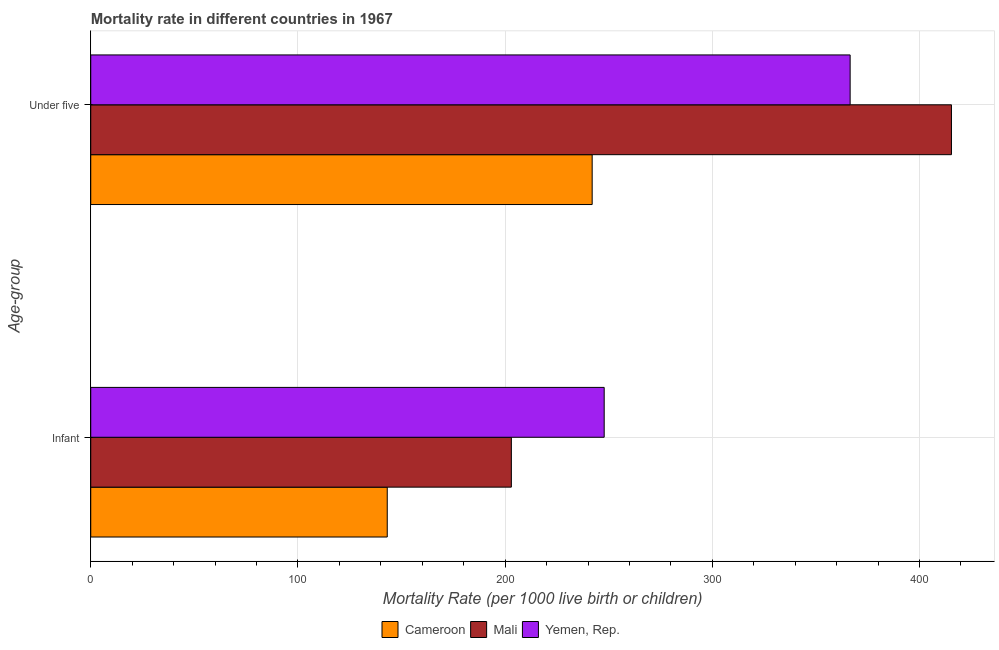How many different coloured bars are there?
Offer a terse response. 3. Are the number of bars per tick equal to the number of legend labels?
Provide a short and direct response. Yes. Are the number of bars on each tick of the Y-axis equal?
Your answer should be compact. Yes. What is the label of the 2nd group of bars from the top?
Provide a short and direct response. Infant. What is the under-5 mortality rate in Mali?
Your answer should be compact. 415.4. Across all countries, what is the maximum under-5 mortality rate?
Keep it short and to the point. 415.4. Across all countries, what is the minimum under-5 mortality rate?
Your response must be concise. 242. In which country was the under-5 mortality rate maximum?
Provide a short and direct response. Mali. In which country was the infant mortality rate minimum?
Your answer should be compact. Cameroon. What is the total infant mortality rate in the graph?
Offer a terse response. 593.9. What is the difference between the under-5 mortality rate in Yemen, Rep. and that in Cameroon?
Offer a very short reply. 124.5. What is the difference between the infant mortality rate in Yemen, Rep. and the under-5 mortality rate in Mali?
Your response must be concise. -167.6. What is the average infant mortality rate per country?
Make the answer very short. 197.97. What is the difference between the under-5 mortality rate and infant mortality rate in Cameroon?
Your response must be concise. 98.9. What is the ratio of the infant mortality rate in Mali to that in Yemen, Rep.?
Offer a very short reply. 0.82. What does the 3rd bar from the top in Under five represents?
Keep it short and to the point. Cameroon. What does the 3rd bar from the bottom in Infant represents?
Keep it short and to the point. Yemen, Rep. How many bars are there?
Give a very brief answer. 6. Are all the bars in the graph horizontal?
Offer a very short reply. Yes. How many legend labels are there?
Your answer should be very brief. 3. What is the title of the graph?
Give a very brief answer. Mortality rate in different countries in 1967. Does "Russian Federation" appear as one of the legend labels in the graph?
Ensure brevity in your answer.  No. What is the label or title of the X-axis?
Offer a terse response. Mortality Rate (per 1000 live birth or children). What is the label or title of the Y-axis?
Your response must be concise. Age-group. What is the Mortality Rate (per 1000 live birth or children) of Cameroon in Infant?
Give a very brief answer. 143.1. What is the Mortality Rate (per 1000 live birth or children) of Mali in Infant?
Ensure brevity in your answer.  203. What is the Mortality Rate (per 1000 live birth or children) of Yemen, Rep. in Infant?
Provide a short and direct response. 247.8. What is the Mortality Rate (per 1000 live birth or children) of Cameroon in Under five?
Give a very brief answer. 242. What is the Mortality Rate (per 1000 live birth or children) of Mali in Under five?
Provide a succinct answer. 415.4. What is the Mortality Rate (per 1000 live birth or children) of Yemen, Rep. in Under five?
Ensure brevity in your answer.  366.5. Across all Age-group, what is the maximum Mortality Rate (per 1000 live birth or children) of Cameroon?
Give a very brief answer. 242. Across all Age-group, what is the maximum Mortality Rate (per 1000 live birth or children) of Mali?
Your answer should be compact. 415.4. Across all Age-group, what is the maximum Mortality Rate (per 1000 live birth or children) in Yemen, Rep.?
Provide a succinct answer. 366.5. Across all Age-group, what is the minimum Mortality Rate (per 1000 live birth or children) of Cameroon?
Offer a very short reply. 143.1. Across all Age-group, what is the minimum Mortality Rate (per 1000 live birth or children) in Mali?
Provide a short and direct response. 203. Across all Age-group, what is the minimum Mortality Rate (per 1000 live birth or children) of Yemen, Rep.?
Your answer should be compact. 247.8. What is the total Mortality Rate (per 1000 live birth or children) in Cameroon in the graph?
Offer a terse response. 385.1. What is the total Mortality Rate (per 1000 live birth or children) of Mali in the graph?
Offer a very short reply. 618.4. What is the total Mortality Rate (per 1000 live birth or children) of Yemen, Rep. in the graph?
Keep it short and to the point. 614.3. What is the difference between the Mortality Rate (per 1000 live birth or children) of Cameroon in Infant and that in Under five?
Your response must be concise. -98.9. What is the difference between the Mortality Rate (per 1000 live birth or children) of Mali in Infant and that in Under five?
Provide a succinct answer. -212.4. What is the difference between the Mortality Rate (per 1000 live birth or children) of Yemen, Rep. in Infant and that in Under five?
Offer a very short reply. -118.7. What is the difference between the Mortality Rate (per 1000 live birth or children) of Cameroon in Infant and the Mortality Rate (per 1000 live birth or children) of Mali in Under five?
Your answer should be compact. -272.3. What is the difference between the Mortality Rate (per 1000 live birth or children) of Cameroon in Infant and the Mortality Rate (per 1000 live birth or children) of Yemen, Rep. in Under five?
Give a very brief answer. -223.4. What is the difference between the Mortality Rate (per 1000 live birth or children) in Mali in Infant and the Mortality Rate (per 1000 live birth or children) in Yemen, Rep. in Under five?
Make the answer very short. -163.5. What is the average Mortality Rate (per 1000 live birth or children) in Cameroon per Age-group?
Ensure brevity in your answer.  192.55. What is the average Mortality Rate (per 1000 live birth or children) in Mali per Age-group?
Ensure brevity in your answer.  309.2. What is the average Mortality Rate (per 1000 live birth or children) in Yemen, Rep. per Age-group?
Offer a very short reply. 307.15. What is the difference between the Mortality Rate (per 1000 live birth or children) in Cameroon and Mortality Rate (per 1000 live birth or children) in Mali in Infant?
Give a very brief answer. -59.9. What is the difference between the Mortality Rate (per 1000 live birth or children) in Cameroon and Mortality Rate (per 1000 live birth or children) in Yemen, Rep. in Infant?
Keep it short and to the point. -104.7. What is the difference between the Mortality Rate (per 1000 live birth or children) in Mali and Mortality Rate (per 1000 live birth or children) in Yemen, Rep. in Infant?
Ensure brevity in your answer.  -44.8. What is the difference between the Mortality Rate (per 1000 live birth or children) of Cameroon and Mortality Rate (per 1000 live birth or children) of Mali in Under five?
Offer a very short reply. -173.4. What is the difference between the Mortality Rate (per 1000 live birth or children) of Cameroon and Mortality Rate (per 1000 live birth or children) of Yemen, Rep. in Under five?
Provide a short and direct response. -124.5. What is the difference between the Mortality Rate (per 1000 live birth or children) in Mali and Mortality Rate (per 1000 live birth or children) in Yemen, Rep. in Under five?
Give a very brief answer. 48.9. What is the ratio of the Mortality Rate (per 1000 live birth or children) in Cameroon in Infant to that in Under five?
Make the answer very short. 0.59. What is the ratio of the Mortality Rate (per 1000 live birth or children) of Mali in Infant to that in Under five?
Offer a terse response. 0.49. What is the ratio of the Mortality Rate (per 1000 live birth or children) of Yemen, Rep. in Infant to that in Under five?
Keep it short and to the point. 0.68. What is the difference between the highest and the second highest Mortality Rate (per 1000 live birth or children) of Cameroon?
Provide a succinct answer. 98.9. What is the difference between the highest and the second highest Mortality Rate (per 1000 live birth or children) of Mali?
Provide a succinct answer. 212.4. What is the difference between the highest and the second highest Mortality Rate (per 1000 live birth or children) in Yemen, Rep.?
Provide a succinct answer. 118.7. What is the difference between the highest and the lowest Mortality Rate (per 1000 live birth or children) in Cameroon?
Ensure brevity in your answer.  98.9. What is the difference between the highest and the lowest Mortality Rate (per 1000 live birth or children) in Mali?
Your response must be concise. 212.4. What is the difference between the highest and the lowest Mortality Rate (per 1000 live birth or children) in Yemen, Rep.?
Offer a very short reply. 118.7. 